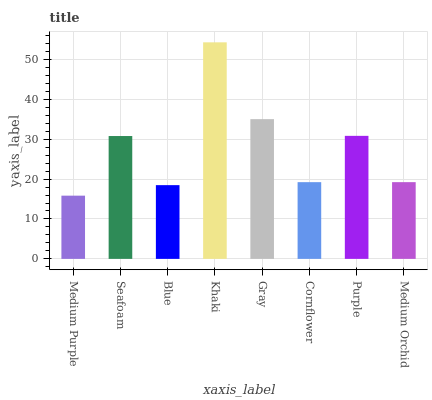Is Medium Purple the minimum?
Answer yes or no. Yes. Is Khaki the maximum?
Answer yes or no. Yes. Is Seafoam the minimum?
Answer yes or no. No. Is Seafoam the maximum?
Answer yes or no. No. Is Seafoam greater than Medium Purple?
Answer yes or no. Yes. Is Medium Purple less than Seafoam?
Answer yes or no. Yes. Is Medium Purple greater than Seafoam?
Answer yes or no. No. Is Seafoam less than Medium Purple?
Answer yes or no. No. Is Seafoam the high median?
Answer yes or no. Yes. Is Medium Orchid the low median?
Answer yes or no. Yes. Is Cornflower the high median?
Answer yes or no. No. Is Purple the low median?
Answer yes or no. No. 